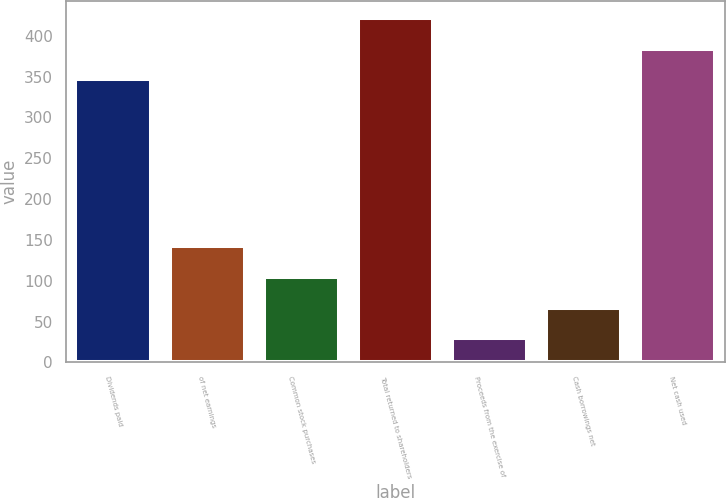Convert chart to OTSL. <chart><loc_0><loc_0><loc_500><loc_500><bar_chart><fcel>Dividends paid<fcel>of net earnings<fcel>Common stock purchases<fcel>Total returned to shareholders<fcel>Proceeds from the exercise of<fcel>Cash borrowings net<fcel>Net cash used<nl><fcel>346.6<fcel>142.34<fcel>104.66<fcel>421.96<fcel>29.3<fcel>66.98<fcel>384.28<nl></chart> 